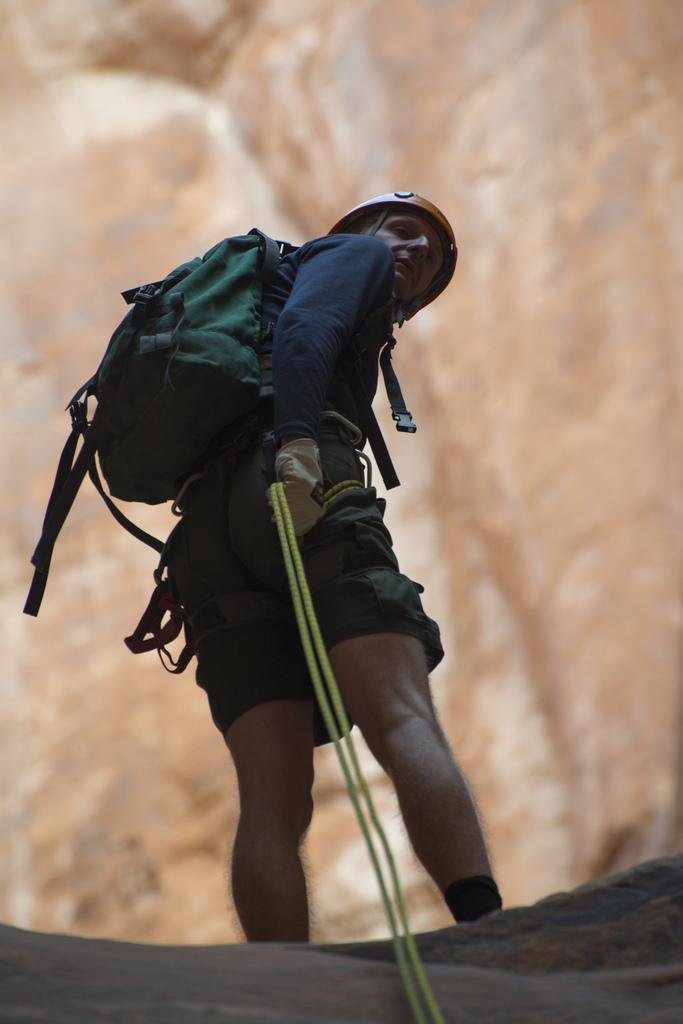Who is present in the image? There is a man in the image. What is the man wearing on his body? The man is wearing a bag. What is the man wearing on his head? The man is wearing a helmet on his head. What is the man holding in his hand? The man is holding a rope in his hand. What type of attraction is the man celebrating his birthday at in the image? There is no indication of an attraction or a birthday celebration in the image; it only shows a man wearing a bag, helmet, and holding a rope. 